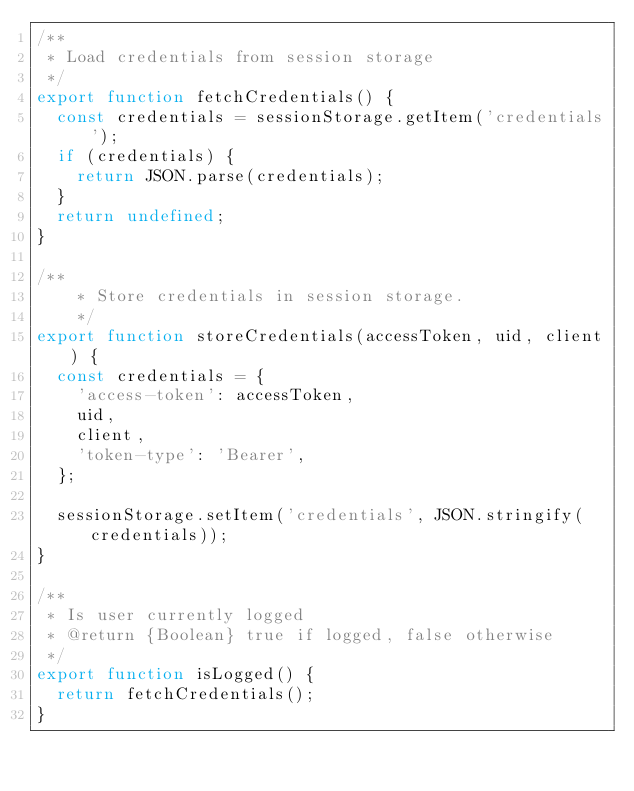Convert code to text. <code><loc_0><loc_0><loc_500><loc_500><_JavaScript_>/**
 * Load credentials from session storage
 */
export function fetchCredentials() {
  const credentials = sessionStorage.getItem('credentials');
  if (credentials) {
    return JSON.parse(credentials);
  }
  return undefined;
}

/**
    * Store credentials in session storage.
    */
export function storeCredentials(accessToken, uid, client) {
  const credentials = {
    'access-token': accessToken,
    uid,
    client,
    'token-type': 'Bearer',
  };

  sessionStorage.setItem('credentials', JSON.stringify(credentials));
}

/**
 * Is user currently logged
 * @return {Boolean} true if logged, false otherwise
 */
export function isLogged() {
  return fetchCredentials();
}
</code> 